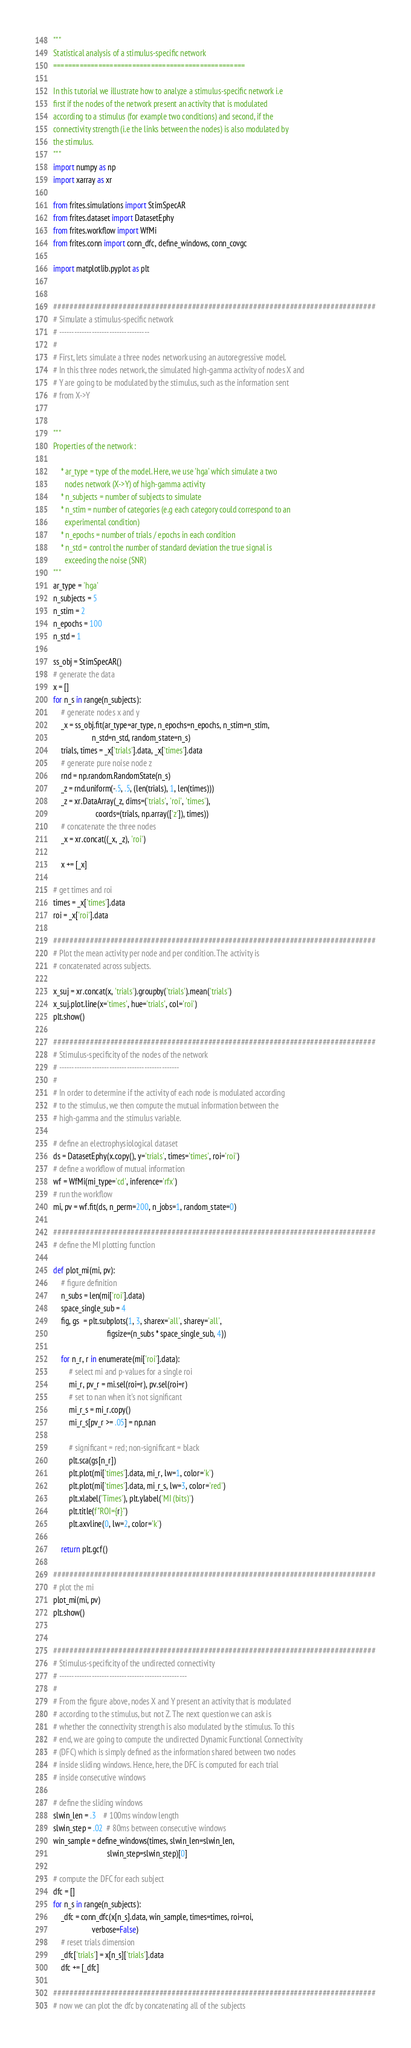Convert code to text. <code><loc_0><loc_0><loc_500><loc_500><_Python_>"""
Statistical analysis of a stimulus-specific network
===================================================

In this tutorial we illustrate how to analyze a stimulus-specific network i.e
first if the nodes of the network present an activity that is modulated
according to a stimulus (for example two conditions) and second, if the
connectivity strength (i.e the links between the nodes) is also modulated by
the stimulus.
"""
import numpy as np
import xarray as xr

from frites.simulations import StimSpecAR
from frites.dataset import DatasetEphy
from frites.workflow import WfMi
from frites.conn import conn_dfc, define_windows, conn_covgc

import matplotlib.pyplot as plt


###############################################################################
# Simulate a stimulus-specific network
# ------------------------------------
#
# First, lets simulate a three nodes network using an autoregressive model.
# In this three nodes network, the simulated high-gamma activity of nodes X and
# Y are going to be modulated by the stimulus, such as the information sent
# from X->Y


"""
Properties of the network :

    * ar_type = type of the model. Here, we use 'hga' which simulate a two
      nodes network (X->Y) of high-gamma activity
    * n_subjects = number of subjects to simulate
    * n_stim = number of categories (e.g each category could correspond to an
      experimental condition)
    * n_epochs = number of trials / epochs in each condition
    * n_std = control the number of standard deviation the true signal is
      exceeding the noise (SNR)
"""
ar_type = 'hga'
n_subjects = 5
n_stim = 2
n_epochs = 100
n_std = 1

ss_obj = StimSpecAR()
# generate the data
x = []
for n_s in range(n_subjects):
    # generate nodes x and y
    _x = ss_obj.fit(ar_type=ar_type, n_epochs=n_epochs, n_stim=n_stim,
                    n_std=n_std, random_state=n_s)
    trials, times = _x['trials'].data, _x['times'].data
    # generate pure noise node z
    rnd = np.random.RandomState(n_s)
    _z = rnd.uniform(-.5, .5, (len(trials), 1, len(times)))
    _z = xr.DataArray(_z, dims=('trials', 'roi', 'times'),
                      coords=(trials, np.array(['z']), times))
    # concatenate the three nodes
    _x = xr.concat((_x, _z), 'roi')

    x += [_x]

# get times and roi
times = _x['times'].data
roi = _x['roi'].data

###############################################################################
# Plot the mean activity per node and per condition. The activity is
# concatenated across subjects.

x_suj = xr.concat(x, 'trials').groupby('trials').mean('trials')
x_suj.plot.line(x='times', hue='trials', col='roi')
plt.show()

###############################################################################
# Stimulus-specificity of the nodes of the network
# ------------------------------------------------
#
# In order to determine if the activity of each node is modulated according
# to the stimulus, we then compute the mutual information between the
# high-gamma and the stimulus variable.

# define an electrophysiological dataset
ds = DatasetEphy(x.copy(), y='trials', times='times', roi='roi')
# define a workflow of mutual information
wf = WfMi(mi_type='cd', inference='rfx')
# run the workflow
mi, pv = wf.fit(ds, n_perm=200, n_jobs=1, random_state=0)

###############################################################################
# define the MI plotting function

def plot_mi(mi, pv):
    # figure definition
    n_subs = len(mi['roi'].data)
    space_single_sub = 4
    fig, gs  = plt.subplots(1, 3, sharex='all', sharey='all',
                            figsize=(n_subs * space_single_sub, 4))

    for n_r, r in enumerate(mi['roi'].data):
        # select mi and p-values for a single roi
        mi_r, pv_r = mi.sel(roi=r), pv.sel(roi=r)
        # set to nan when it's not significant
        mi_r_s = mi_r.copy()
        mi_r_s[pv_r >= .05] = np.nan

        # significant = red; non-significant = black
        plt.sca(gs[n_r])
        plt.plot(mi['times'].data, mi_r, lw=1, color='k')
        plt.plot(mi['times'].data, mi_r_s, lw=3, color='red')
        plt.xlabel('Times'), plt.ylabel('MI (bits)')
        plt.title(f"ROI={r}")
        plt.axvline(0, lw=2, color='k')

    return plt.gcf()

###############################################################################
# plot the mi
plot_mi(mi, pv)
plt.show()


###############################################################################
# Stimulus-specificity of the undirected connectivity
# ---------------------------------------------------
#
# From the figure above, nodes X and Y present an activity that is modulated
# according to the stimulus, but not Z. The next question we can ask is
# whether the connectivity strength is also modulated by the stimulus. To this
# end, we are going to compute the undirected Dynamic Functional Connectivity
# (DFC) which is simply defined as the information shared between two nodes
# inside sliding windows. Hence, here, the DFC is computed for each trial
# inside consecutive windows

# define the sliding windows
slwin_len = .3    # 100ms window length
slwin_step = .02  # 80ms between consecutive windows
win_sample = define_windows(times, slwin_len=slwin_len,
                            slwin_step=slwin_step)[0]

# compute the DFC for each subject
dfc = []
for n_s in range(n_subjects):
    _dfc = conn_dfc(x[n_s].data, win_sample, times=times, roi=roi,
                    verbose=False)
    # reset trials dimension
    _dfc['trials'] = x[n_s]['trials'].data
    dfc += [_dfc]

###############################################################################
# now we can plot the dfc by concatenating all of the subjects
</code> 